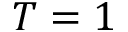Convert formula to latex. <formula><loc_0><loc_0><loc_500><loc_500>T = 1</formula> 